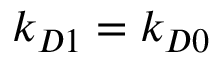<formula> <loc_0><loc_0><loc_500><loc_500>k _ { D 1 } = k _ { D 0 }</formula> 